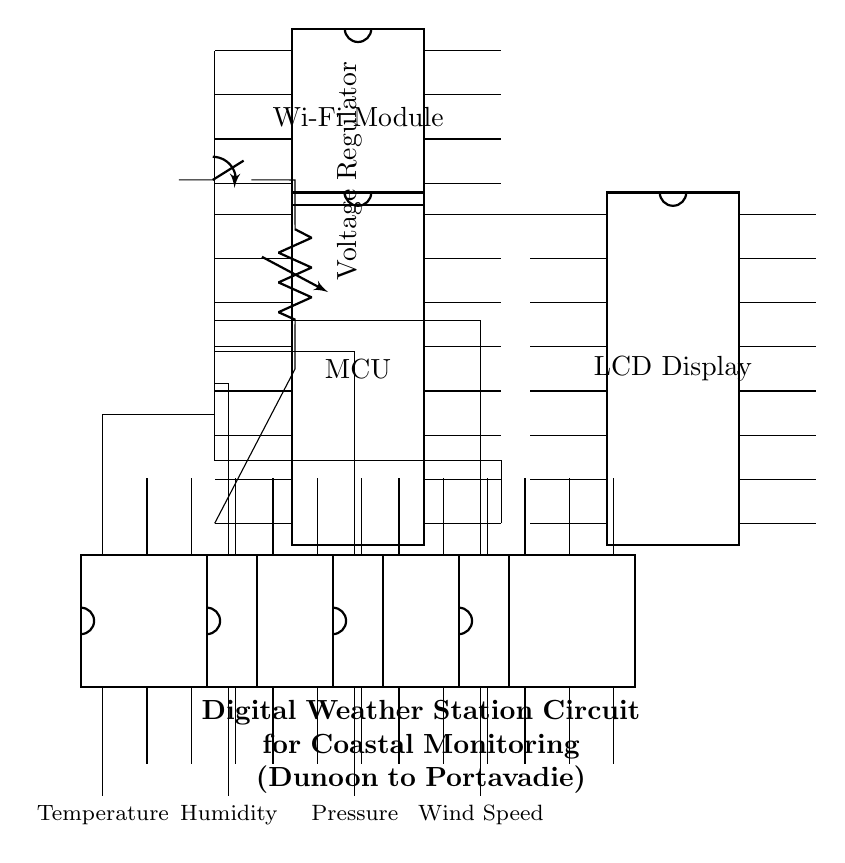What type of microcontroller is used? The diagram shows a dip chip with 16 pins labeled as 'MCU', which indicates it's a microcontroller.
Answer: Microcontroller How many sensors are present in the circuit? The diagram displays four sensors: Temperature, Humidity, Pressure, and Wind Speed; these are clear components connected to the microcontroller.
Answer: Four What is the power source for the circuit? The circuit diagram includes a battery symbol labeled 'BAT', which serves as the power supply.
Answer: Battery Which component connects to the Wi-Fi module? The diagram shows a connection from the microcontroller pin to the Wi-Fi module, indicating that the MCU interfaces with the Wi-Fi module for wireless communication.
Answer: Microcontroller What voltage regulation component is included? The circuit features a voltage regulator component indicated in the connection from the battery leading to the microcontroller, which ensures consistent voltage supply.
Answer: Voltage Regulator How does the data flow from the sensors to the display? Data flows from each sensor to the microcontroller via individual connections, from there, it connects to the LCD display, indicating that the microcontroller processes sensor data before sending it to the display.
Answer: Through microcontroller What is the main purpose of the circuit? The title of the circuit highlights its purpose as a digital weather station for monitoring coastal conditions between Dunoon and Portavadie, indicating its intended functionality.
Answer: Weather monitoring 